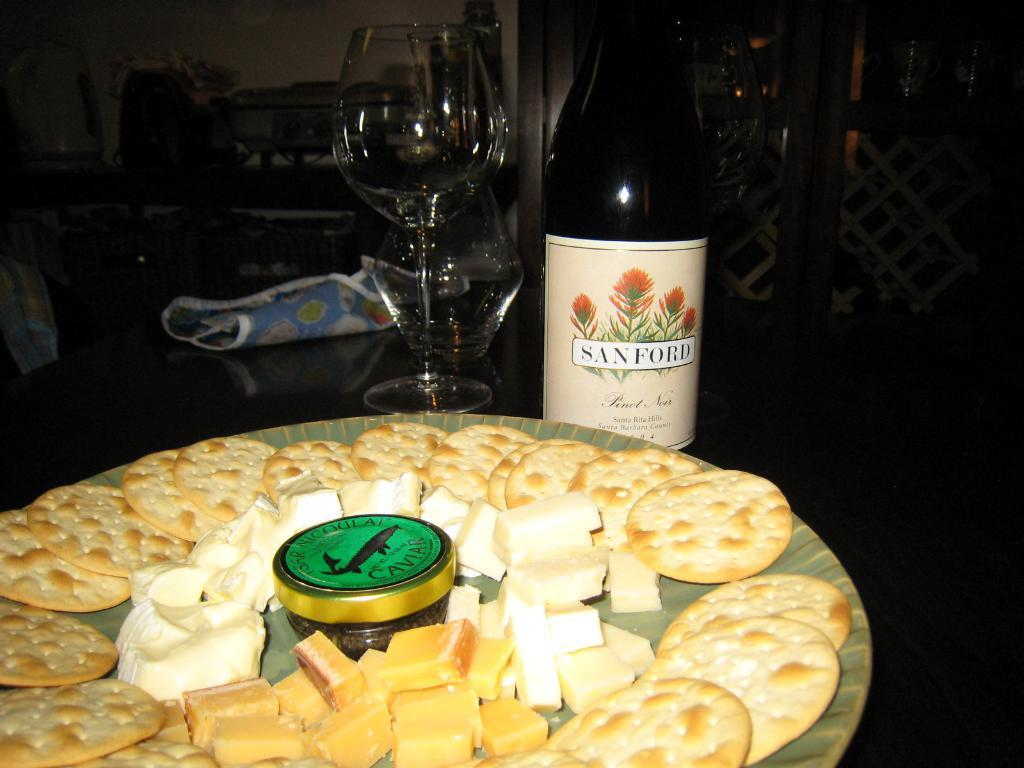Provide a one-sentence caption for the provided image. a plate of cheese and crackers and a bottle of sanford by it. 